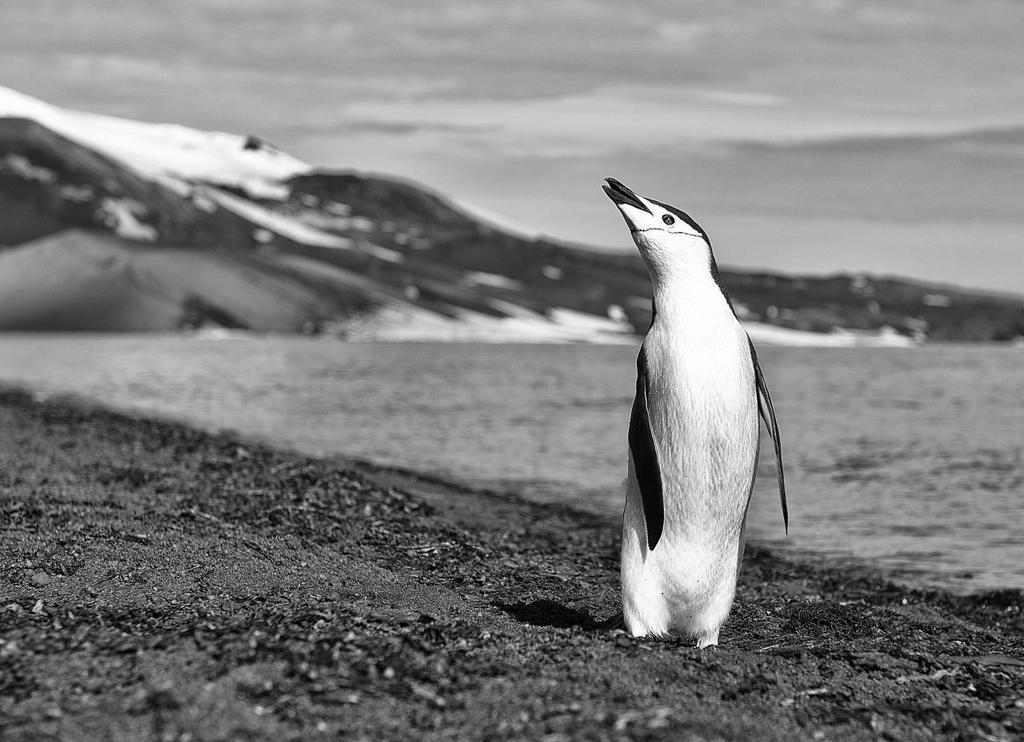What animal is in the picture? There is a penguin in the picture. What surface is the penguin standing on? The penguin is standing on the sand. What can be seen in the distance behind the penguin? There is water visible in the background, and there might be a rock in the background. What type of terrain is at the bottom of the image? The bottom of the image contains sand. What type of yarn is the penguin using to knit a sweater in the image? There is no yarn or sweater in the image; it only shows a penguin standing on the sand with water and possibly a rock in the background. 